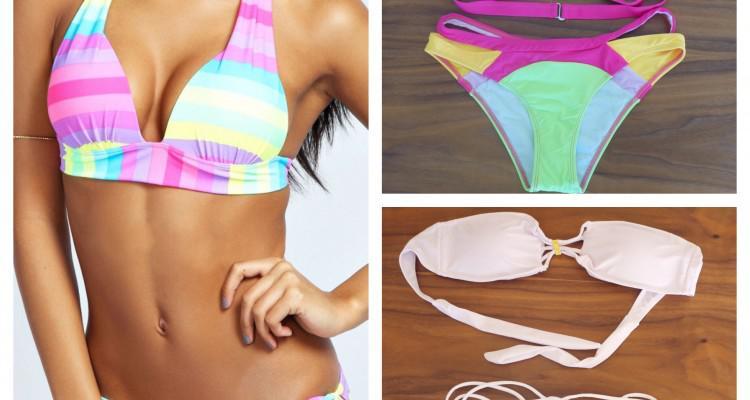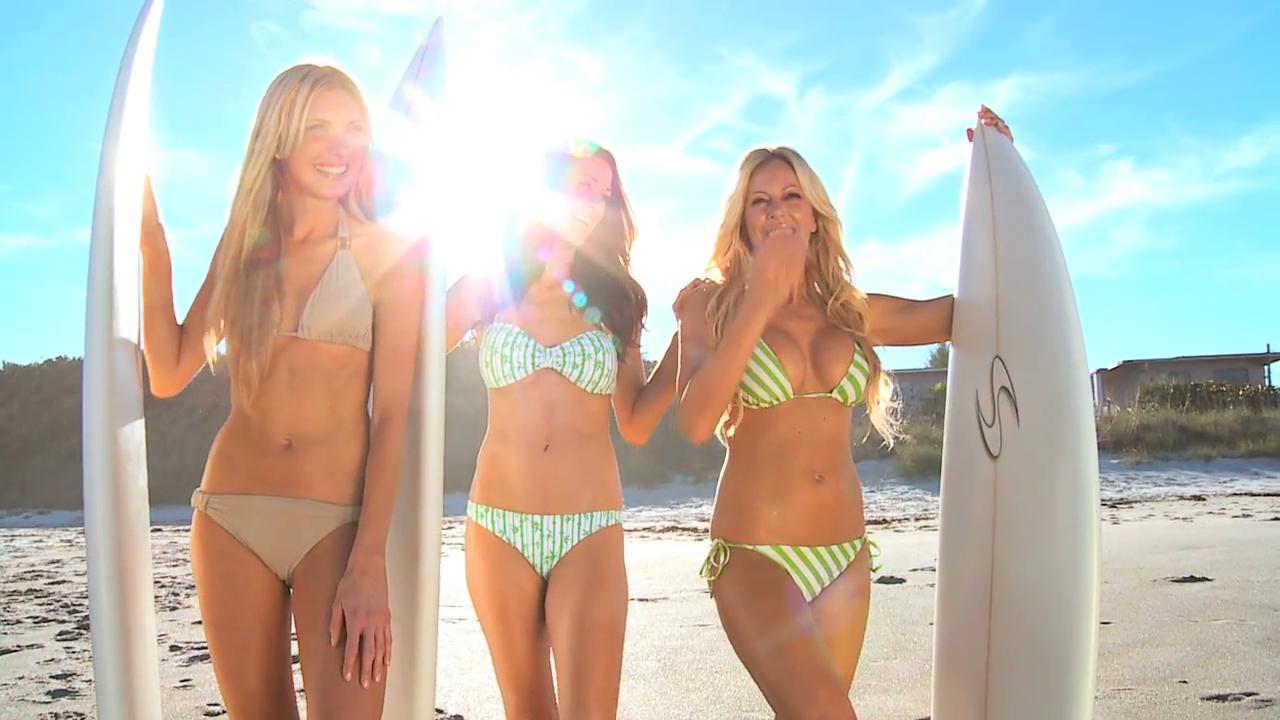The first image is the image on the left, the second image is the image on the right. Given the left and right images, does the statement "At least one image depicts a trio of rear-facing arm-linked models in front of water." hold true? Answer yes or no. No. The first image is the image on the left, the second image is the image on the right. Assess this claim about the two images: "Three women are wearing bikinis in each of the images.". Correct or not? Answer yes or no. No. 